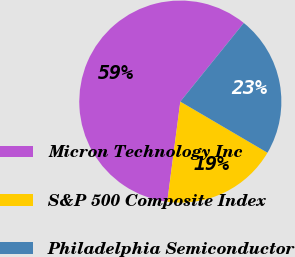Convert chart. <chart><loc_0><loc_0><loc_500><loc_500><pie_chart><fcel>Micron Technology Inc<fcel>S&P 500 Composite Index<fcel>Philadelphia Semiconductor<nl><fcel>58.74%<fcel>18.62%<fcel>22.63%<nl></chart> 